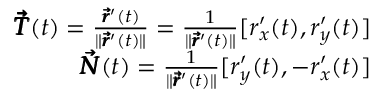Convert formula to latex. <formula><loc_0><loc_0><loc_500><loc_500>\begin{array} { r } { \pm b { \vec { T } } ( t ) = \frac { \pm b { \vec { r } } ^ { \prime } ( t ) } { \| \pm b { \vec { r } } ^ { \prime } ( t ) \| } = \frac { 1 } { \| \pm b { \vec { r } } ^ { \prime } ( t ) \| } [ r _ { x } ^ { \prime } ( t ) , r _ { y } ^ { \prime } ( t ) ] } \\ { \pm b { \vec { N } } ( t ) = \frac { 1 } { \| \pm b { \vec { r } } ^ { \prime } ( t ) \| } [ r _ { y } ^ { \prime } ( t ) , - r _ { x } ^ { \prime } ( t ) ] } \end{array}</formula> 